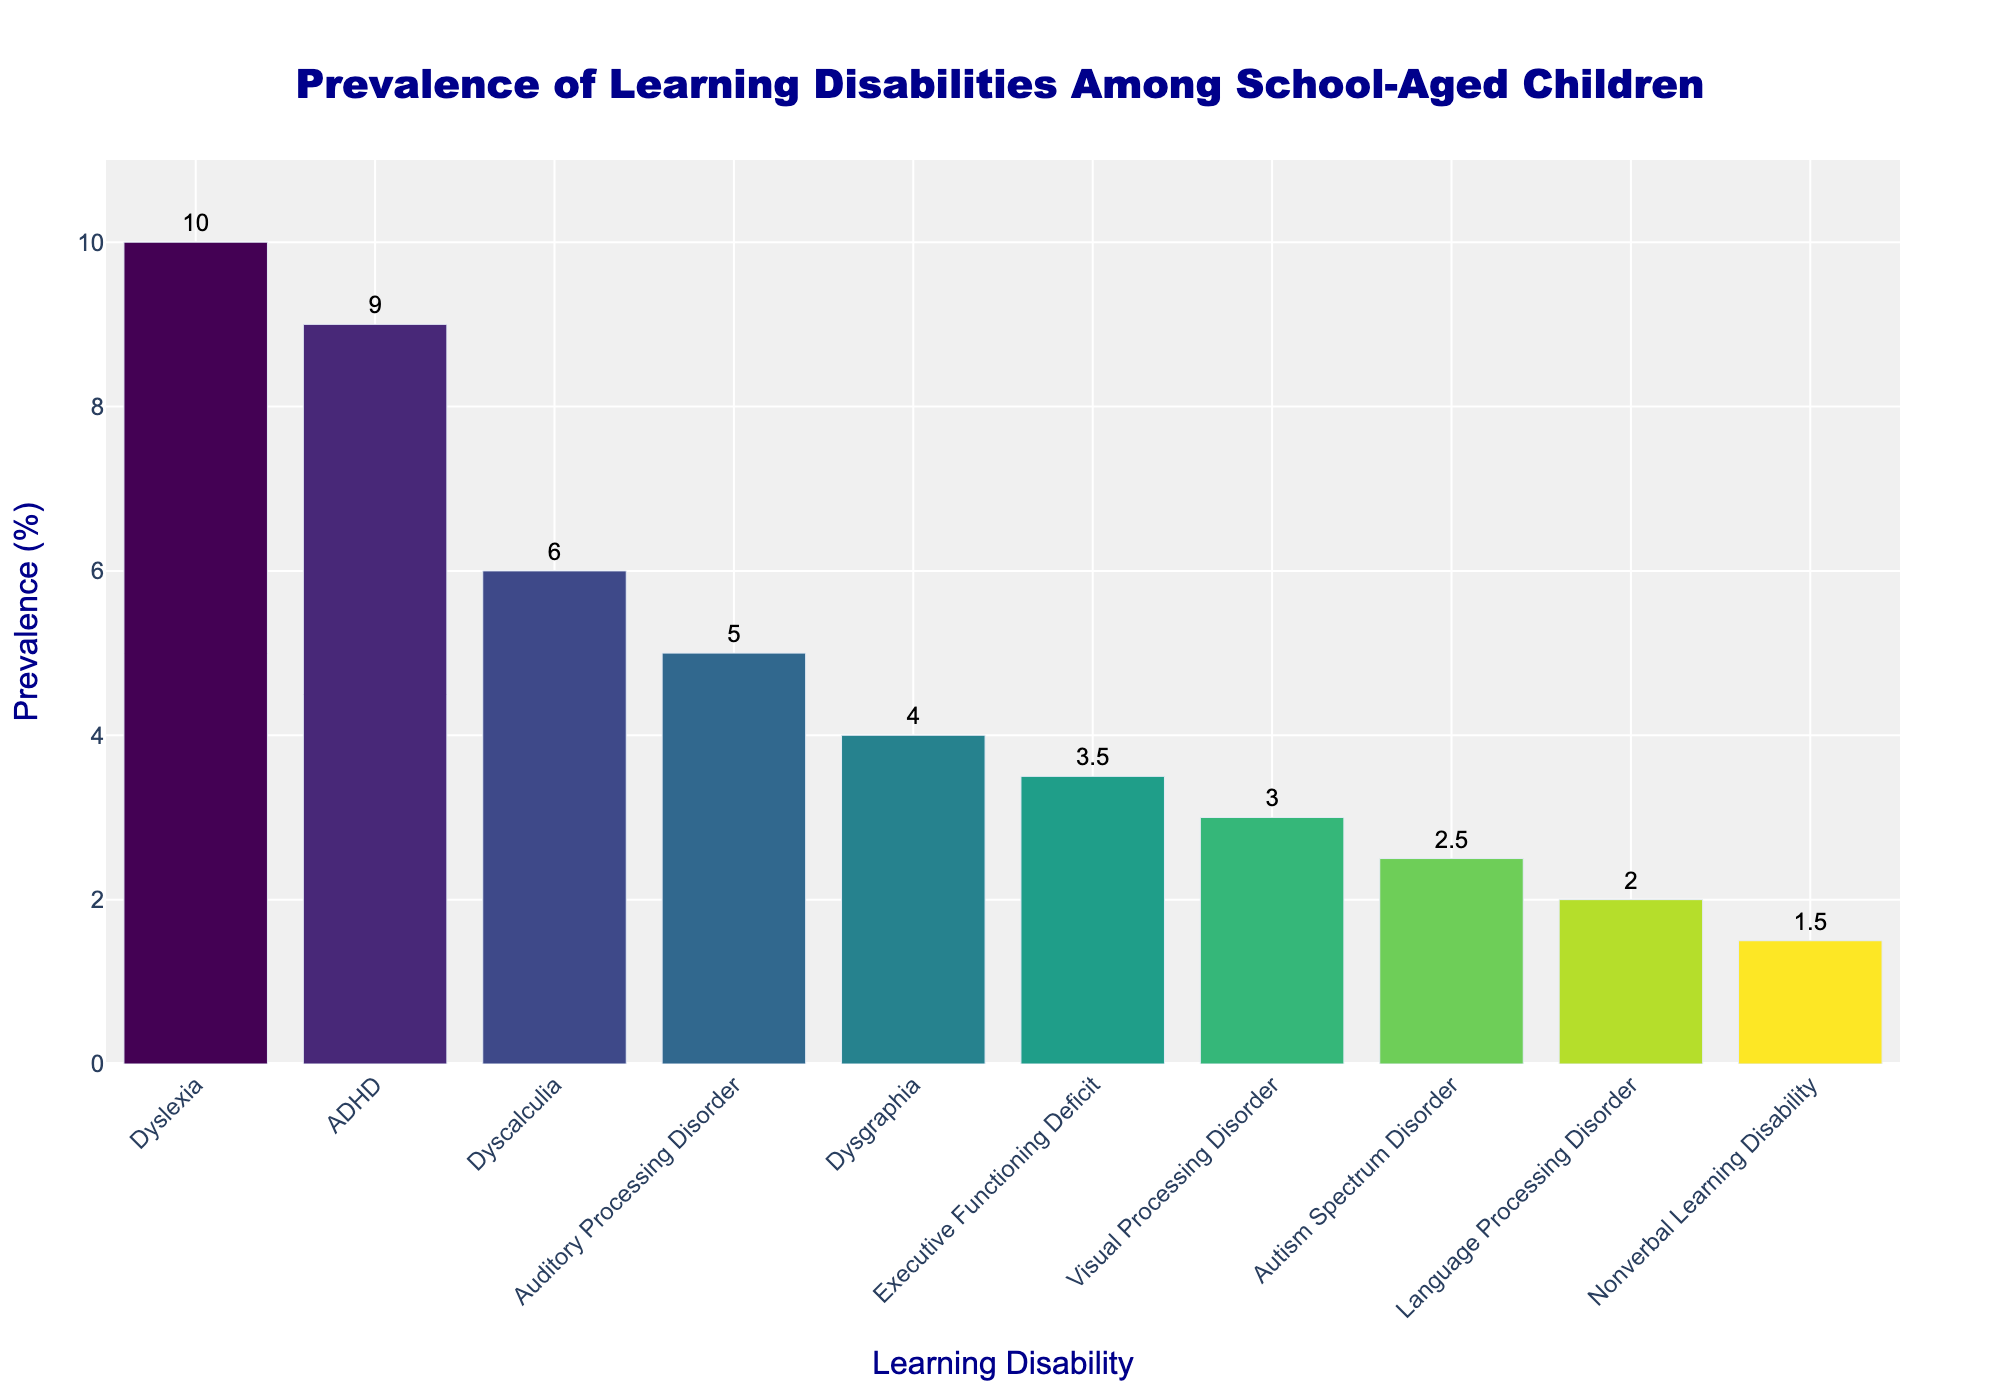Which learning disability has the highest prevalence among school-aged children? The bar chart shows the prevalence of various learning disabilities. The height of the bar corresponding to Dyslexia is the tallest, indicating it has the highest prevalence.
Answer: Dyslexia Compare the prevalence of ADHD and Dyscalculia. Which one is higher? The figure shows a bar representing ADHD at 9% and another representing Dyscalculia at 6%. The bar for ADHD is taller.
Answer: ADHD What is the difference in prevalence between the most and least common learning disabilities? The tallest bar (Dyslexia) represents 10% and the shortest bar (Nonverbal Learning Disability) represents 1.5%. The difference can be calculated as 10% - 1.5%.
Answer: 8.5% What is the average prevalence of Dysgraphia, Auditory Processing Disorder, and Visual Processing Disorder? Calculate the average by summing the prevalence values (4%, 5%, 3%) and then dividing by the number of disabilities (3). (4% + 5% + 3%) / 3 = 4%.
Answer: 4% Are there any learning disabilities with the same prevalence rate? By visually inspecting the bars, none of the heights are exactly the same. Each prevalence percentage is unique across the different learning disabilities.
Answer: No How many learning disabilities have a prevalence rate greater than 5%? Count the number of bars with heights exceeding the 5% mark. These are Dyslexia, ADHD, and Dyscalculia.
Answer: 3 Which learning disabilities have a prevalence rate lower than Executive Functioning Deficit? Executive Functioning Deficit has a prevalence of 3.5%. The learning disabilities with lower values are Visual Processing Disorder, Language Processing Disorder, Nonverbal Learning Disability, and Autism Spectrum Disorder.
Answer: Four What is the median prevalence value of all the learning disabilities listed? Arrange the prevalence values in ascending order: 1.5%, 2%, 2.5%, 3%, 3.5%, 4%, 5%, 6%, 9%, 10%. Since there are an even number of data points (10), the median is the average of the 5th (3.5%) and 6th (4%) values.
Answer: 3.75% Which learning disability falls exactly in the middle in terms of prevalence? With the sorted prevalence order, the learning disability in the middle (at position 5 when ordered) is Executive Functioning Deficit at 3.5%.
Answer: Executive Functioning Deficit 